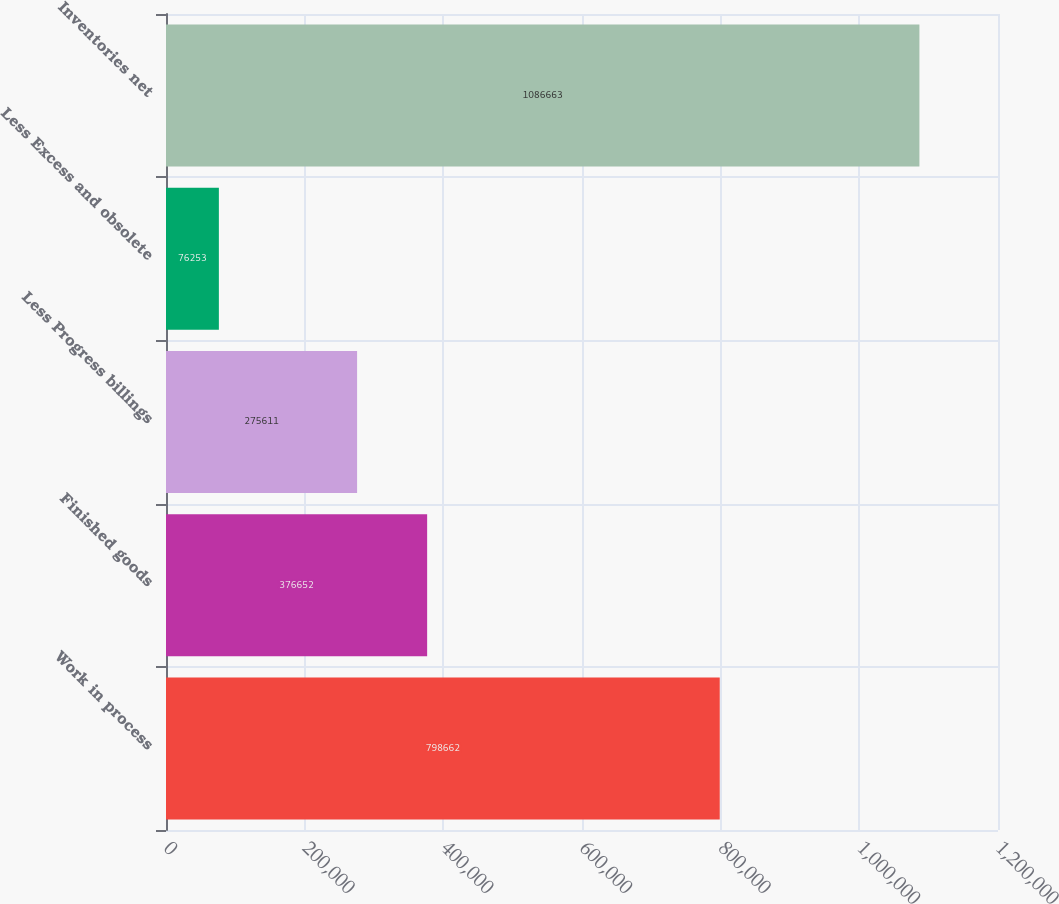Convert chart to OTSL. <chart><loc_0><loc_0><loc_500><loc_500><bar_chart><fcel>Work in process<fcel>Finished goods<fcel>Less Progress billings<fcel>Less Excess and obsolete<fcel>Inventories net<nl><fcel>798662<fcel>376652<fcel>275611<fcel>76253<fcel>1.08666e+06<nl></chart> 